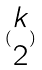Convert formula to latex. <formula><loc_0><loc_0><loc_500><loc_500>( \begin{matrix} k \\ 2 \end{matrix} )</formula> 